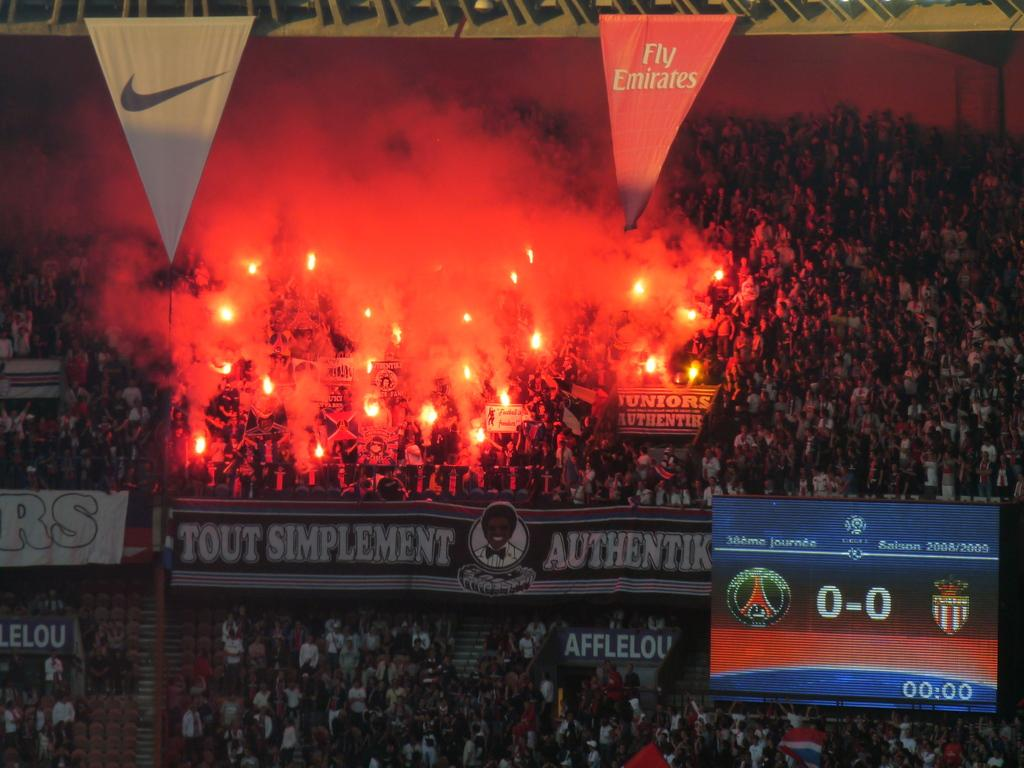<image>
Present a compact description of the photo's key features. A stadium filled with people with a Nike and Fly Emirates banner handing above the crowd. 